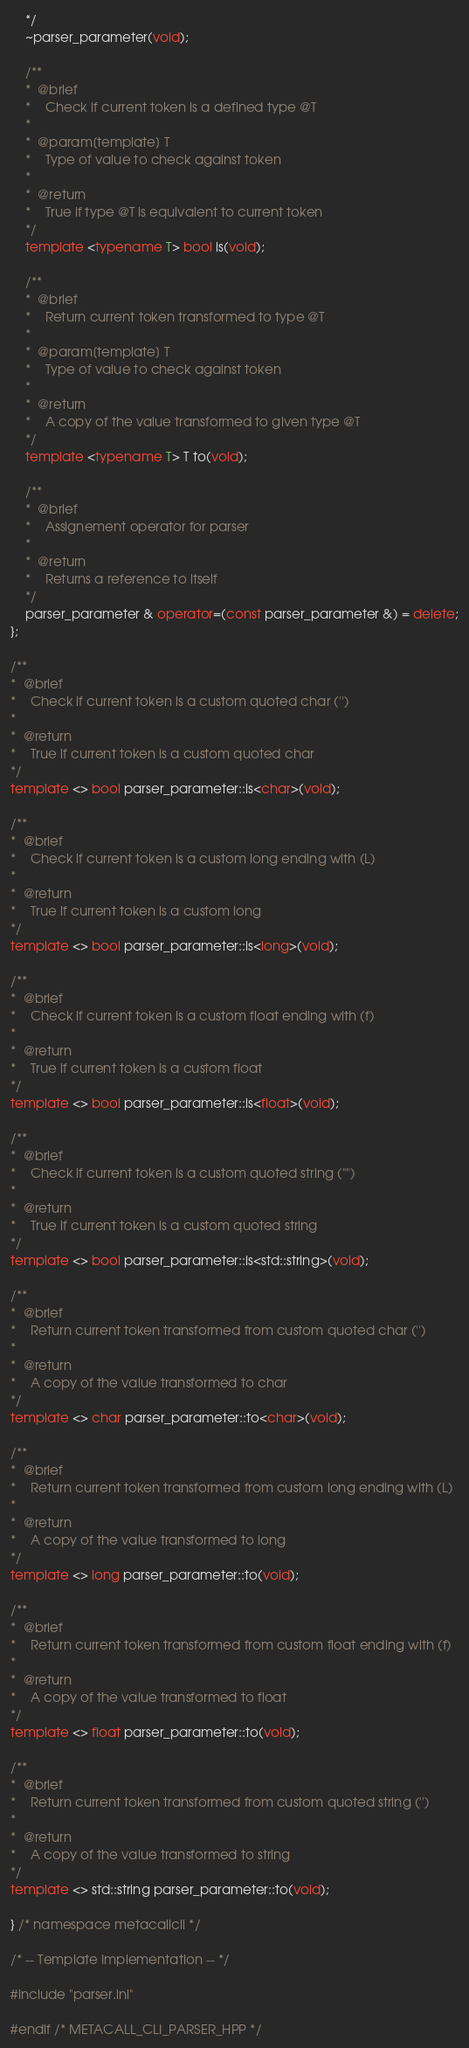Convert code to text. <code><loc_0><loc_0><loc_500><loc_500><_C++_>	*/
	~parser_parameter(void);

	/**
	*  @brief
	*    Check if current token is a defined type @T
	*
	*  @param[template] T
	*    Type of value to check against token
	*
	*  @return
	*    True if type @T is equivalent to current token
	*/
	template <typename T> bool is(void);

	/**
	*  @brief
	*    Return current token transformed to type @T
	*
	*  @param[template] T
	*    Type of value to check against token
	*
	*  @return
	*    A copy of the value transformed to given type @T
	*/
	template <typename T> T to(void);

	/**
	*  @brief
	*    Assignement operator for parser
	*
	*  @return
	*    Returns a reference to itself
	*/
	parser_parameter & operator=(const parser_parameter &) = delete;
};

/**
*  @brief
*    Check if current token is a custom quoted char ('')
*
*  @return
*    True if current token is a custom quoted char
*/
template <> bool parser_parameter::is<char>(void);

/**
*  @brief
*    Check if current token is a custom long ending with (L)
*
*  @return
*    True if current token is a custom long
*/
template <> bool parser_parameter::is<long>(void);

/**
*  @brief
*    Check if current token is a custom float ending with (f)
*
*  @return
*    True if current token is a custom float
*/
template <> bool parser_parameter::is<float>(void);

/**
*  @brief
*    Check if current token is a custom quoted string ("")
*
*  @return
*    True if current token is a custom quoted string
*/
template <> bool parser_parameter::is<std::string>(void);

/**
*  @brief
*    Return current token transformed from custom quoted char ('')
*
*  @return
*    A copy of the value transformed to char
*/
template <> char parser_parameter::to<char>(void);

/**
*  @brief
*    Return current token transformed from custom long ending with (L)
*
*  @return
*    A copy of the value transformed to long
*/
template <> long parser_parameter::to(void);

/**
*  @brief
*    Return current token transformed from custom float ending with (f)
*
*  @return
*    A copy of the value transformed to float
*/
template <> float parser_parameter::to(void);

/**
*  @brief
*    Return current token transformed from custom quoted string ('')
*
*  @return
*    A copy of the value transformed to string
*/
template <> std::string parser_parameter::to(void);

} /* namespace metacallcli */

/* -- Template Implementation -- */

#include "parser.inl"

#endif /* METACALL_CLI_PARSER_HPP */
</code> 